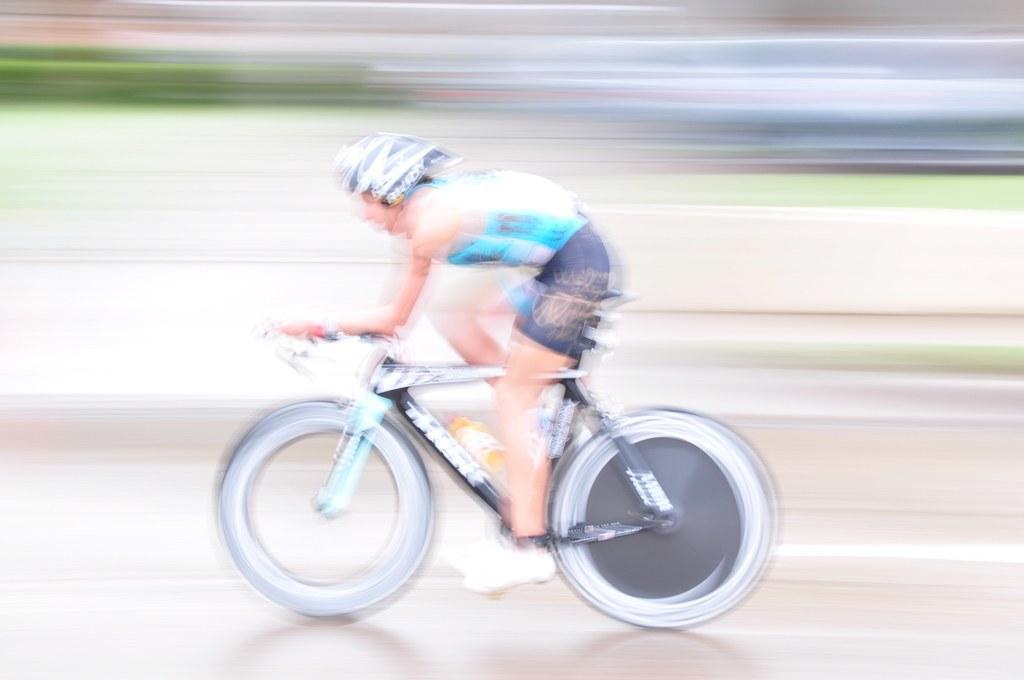In one or two sentences, can you explain what this image depicts? This is the picture of a man in blue t shirt was riding a bicycle. Background of the man is in blur. 